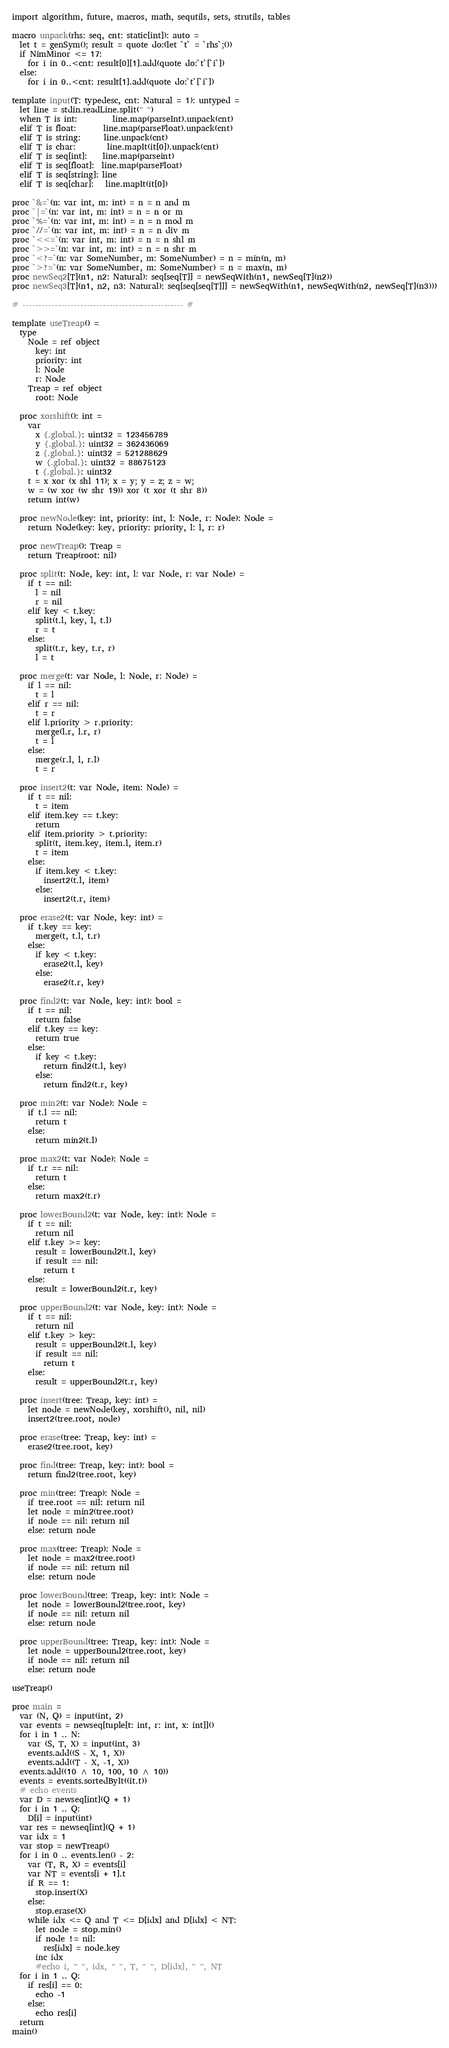Convert code to text. <code><loc_0><loc_0><loc_500><loc_500><_Nim_>import algorithm, future, macros, math, sequtils, sets, strutils, tables

macro unpack(rhs: seq, cnt: static[int]): auto =
  let t = genSym(); result = quote do:(let `t` = `rhs`;())
  if NimMinor <= 17:
    for i in 0..<cnt: result[0][1].add(quote do:`t`[`i`])
  else:
    for i in 0..<cnt: result[1].add(quote do:`t`[`i`])

template input(T: typedesc, cnt: Natural = 1): untyped =
  let line = stdin.readLine.split(" ")
  when T is int:         line.map(parseInt).unpack(cnt)
  elif T is float:       line.map(parseFloat).unpack(cnt)
  elif T is string:      line.unpack(cnt)
  elif T is char:        line.mapIt(it[0]).unpack(cnt)
  elif T is seq[int]:    line.map(parseint)
  elif T is seq[float]:  line.map(parseFloat)
  elif T is seq[string]: line
  elif T is seq[char]:   line.mapIt(it[0])

proc `&=`(n: var int, m: int) = n = n and m
proc `|=`(n: var int, m: int) = n = n or m
proc `%=`(n: var int, m: int) = n = n mod m
proc `//=`(n: var int, m: int) = n = n div m
proc `<<=`(n: var int, m: int) = n = n shl m
proc `>>=`(n: var int, m: int) = n = n shr m
proc `<?=`(n: var SomeNumber, m: SomeNumber) = n = min(n, m)
proc `>?=`(n: var SomeNumber, m: SomeNumber) = n = max(n, m)
proc newSeq2[T](n1, n2: Natural): seq[seq[T]] = newSeqWith(n1, newSeq[T](n2))
proc newSeq3[T](n1, n2, n3: Natural): seq[seq[seq[T]]] = newSeqWith(n1, newSeqWith(n2, newSeq[T](n3)))

# -------------------------------------------------- #

template useTreap() =
  type
    Node = ref object
      key: int
      priority: int
      l: Node
      r: Node
    Treap = ref object
      root: Node
  
  proc xorshift(): int =
    var
      x {.global.}: uint32 = 123456789
      y {.global.}: uint32 = 362436069
      z {.global.}: uint32 = 521288629
      w {.global.}: uint32 = 88675123
      t {.global.}: uint32
    t = x xor (x shl 11); x = y; y = z; z = w;
    w = (w xor (w shr 19)) xor (t xor (t shr 8))
    return int(w)
  
  proc newNode(key: int, priority: int, l: Node, r: Node): Node =
    return Node(key: key, priority: priority, l: l, r: r)
  
  proc newTreap(): Treap =
    return Treap(root: nil)
  
  proc split(t: Node, key: int, l: var Node, r: var Node) =
    if t == nil:
      l = nil
      r = nil
    elif key < t.key:
      split(t.l, key, l, t.l)
      r = t
    else:
      split(t.r, key, t.r, r)
      l = t
  
  proc merge(t: var Node, l: Node, r: Node) =
    if l == nil:
      t = l
    elif r == nil:
      t = r
    elif l.priority > r.priority:
      merge(l.r, l.r, r)
      t = l
    else:
      merge(r.l, l, r.l)
      t = r
  
  proc insert2(t: var Node, item: Node) =
    if t == nil:
      t = item
    elif item.key == t.key:
      return
    elif item.priority > t.priority:
      split(t, item.key, item.l, item.r)
      t = item
    else:
      if item.key < t.key:
        insert2(t.l, item)
      else:
        insert2(t.r, item)
  
  proc erase2(t: var Node, key: int) =
    if t.key == key:
      merge(t, t.l, t.r)
    else:
      if key < t.key:
        erase2(t.l, key)
      else:
        erase2(t.r, key)
  
  proc find2(t: var Node, key: int): bool =
    if t == nil:
      return false
    elif t.key == key:
      return true
    else:
      if key < t.key:
        return find2(t.l, key)
      else:
        return find2(t.r, key)
  
  proc min2(t: var Node): Node =
    if t.l == nil:
      return t
    else:
      return min2(t.l)
  
  proc max2(t: var Node): Node =
    if t.r == nil:
      return t
    else:
      return max2(t.r)
  
  proc lowerBound2(t: var Node, key: int): Node =
    if t == nil:
      return nil
    elif t.key >= key:
      result = lowerBound2(t.l, key)
      if result == nil:
        return t
    else:
      result = lowerBound2(t.r, key)
  
  proc upperBound2(t: var Node, key: int): Node =
    if t == nil:
      return nil
    elif t.key > key:
      result = upperBound2(t.l, key)
      if result == nil:
        return t
    else:
      result = upperBound2(t.r, key)
  
  proc insert(tree: Treap, key: int) =
    let node = newNode(key, xorshift(), nil, nil)
    insert2(tree.root, node)
  
  proc erase(tree: Treap, key: int) =
    erase2(tree.root, key)
  
  proc find(tree: Treap, key: int): bool =
    return find2(tree.root, key)
  
  proc min(tree: Treap): Node =
    if tree.root == nil: return nil
    let node = min2(tree.root)
    if node == nil: return nil
    else: return node
  
  proc max(tree: Treap): Node =
    let node = max2(tree.root)
    if node == nil: return nil
    else: return node

  proc lowerBound(tree: Treap, key: int): Node =
    let node = lowerBound2(tree.root, key)
    if node == nil: return nil
    else: return node

  proc upperBound(tree: Treap, key: int): Node =
    let node = upperBound2(tree.root, key)
    if node == nil: return nil
    else: return node

useTreap()

proc main =
  var (N, Q) = input(int, 2)
  var events = newseq[tuple[t: int, r: int, x: int]]()
  for i in 1 .. N:
    var (S, T, X) = input(int, 3)
    events.add((S - X, 1, X))
    events.add((T - X, -1, X))
  events.add((10 ^ 10, 100, 10 ^ 10))
  events = events.sortedByIt((it.t))
  # echo events
  var D = newseq[int](Q + 1)
  for i in 1 .. Q:
    D[i] = input(int)
  var res = newseq[int](Q + 1)
  var idx = 1
  var stop = newTreap()
  for i in 0 .. events.len() - 2:
    var (T, R, X) = events[i]
    var NT = events[i + 1].t
    if R == 1:
      stop.insert(X)
    else:
      stop.erase(X)
    while idx <= Q and T <= D[idx] and D[idx] < NT:
      let node = stop.min()
      if node != nil:
        res[idx] = node.key
      inc idx
      #echo i, " ", idx, " ", T, " ", D[idx], " ", NT
  for i in 1 .. Q:
    if res[i] == 0:
      echo -1
    else:
      echo res[i]
  return
main()</code> 